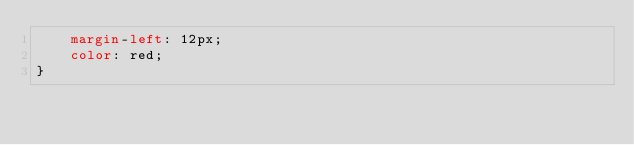<code> <loc_0><loc_0><loc_500><loc_500><_CSS_>    margin-left: 12px;
    color: red;
}</code> 